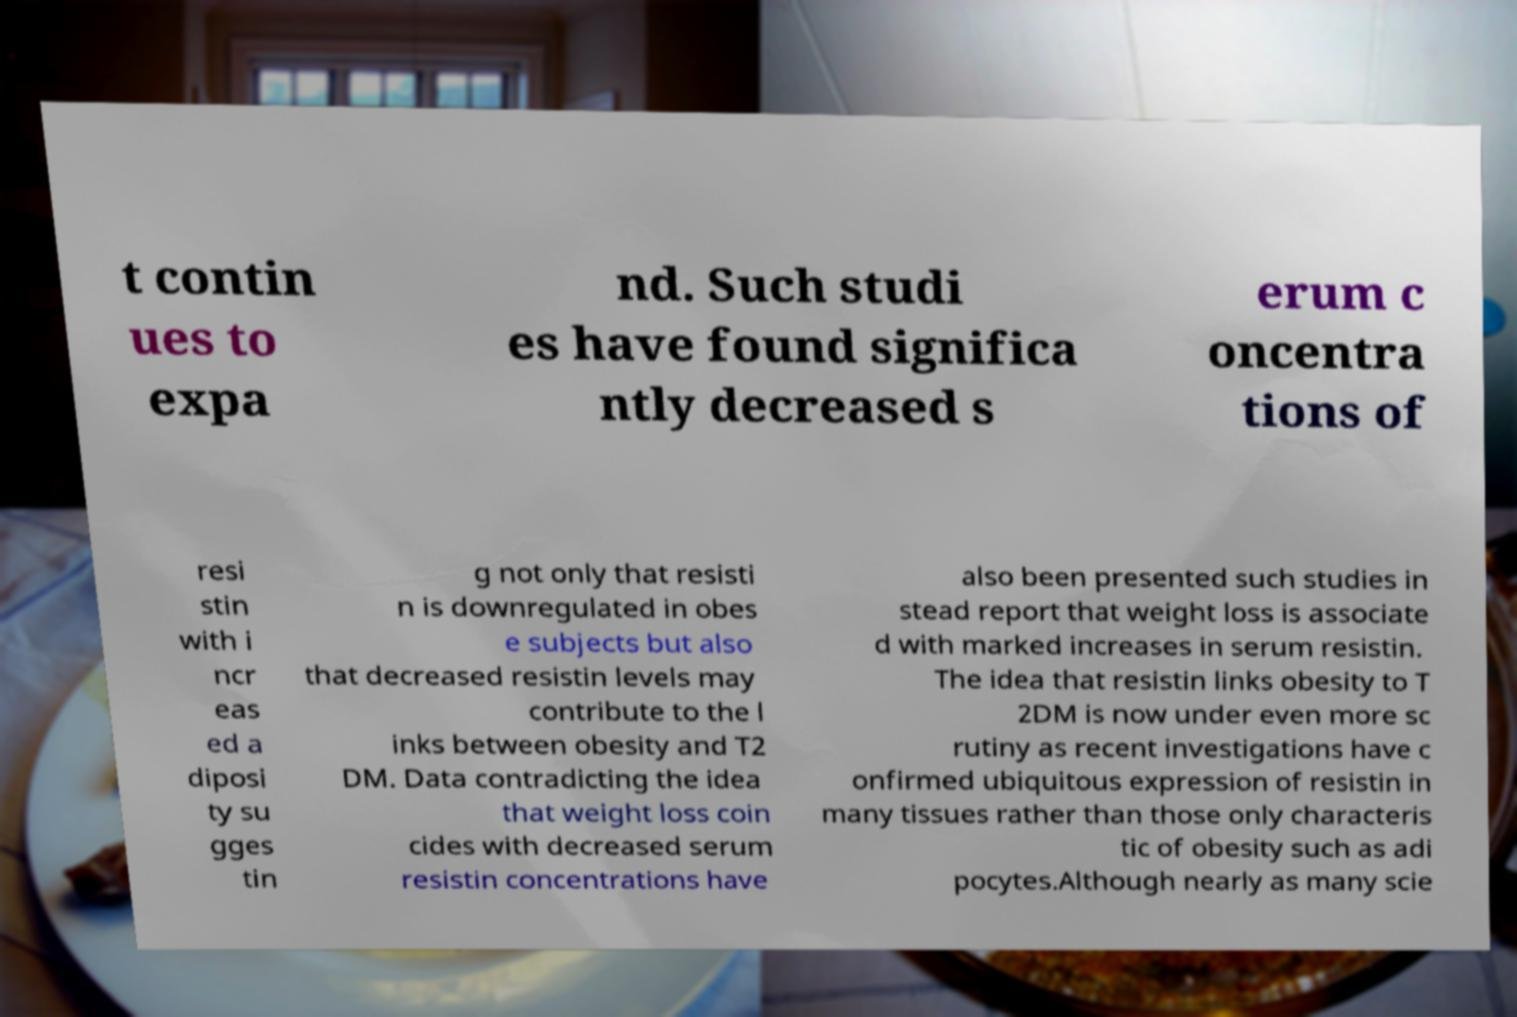What messages or text are displayed in this image? I need them in a readable, typed format. t contin ues to expa nd. Such studi es have found significa ntly decreased s erum c oncentra tions of resi stin with i ncr eas ed a diposi ty su gges tin g not only that resisti n is downregulated in obes e subjects but also that decreased resistin levels may contribute to the l inks between obesity and T2 DM. Data contradicting the idea that weight loss coin cides with decreased serum resistin concentrations have also been presented such studies in stead report that weight loss is associate d with marked increases in serum resistin. The idea that resistin links obesity to T 2DM is now under even more sc rutiny as recent investigations have c onfirmed ubiquitous expression of resistin in many tissues rather than those only characteris tic of obesity such as adi pocytes.Although nearly as many scie 